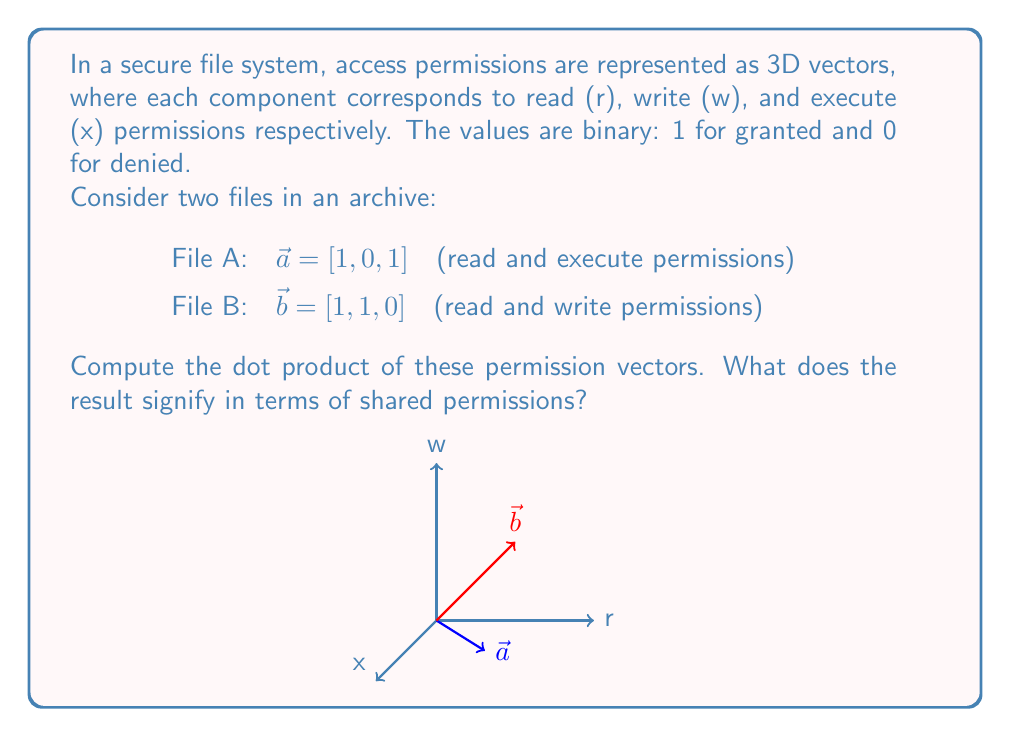Help me with this question. To solve this problem, we'll follow these steps:

1) Recall the formula for the dot product of two 3D vectors:
   $$\vec{a} \cdot \vec{b} = a_1b_1 + a_2b_2 + a_3b_3$$

2) Substitute the values from the given vectors:
   $$\vec{a} = [1, 0, 1]$$
   $$\vec{b} = [1, 1, 0]$$

3) Calculate each component:
   $a_1b_1 = 1 \times 1 = 1$
   $a_2b_2 = 0 \times 1 = 0$
   $a_3b_3 = 1 \times 0 = 0$

4) Sum the results:
   $$\vec{a} \cdot \vec{b} = 1 + 0 + 0 = 1$$

5) Interpret the result:
   The dot product is 1, which indicates that the files share one permission in common. In this case, it's the read (r) permission, as both files have read access (1 in the first component of both vectors).

This calculation method can be useful in quickly identifying shared permissions across multiple files in an archival system, which is relevant for security analysis and access control auditing.
Answer: 1 (shared read permission) 